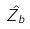<formula> <loc_0><loc_0><loc_500><loc_500>\hat { Z _ { b } }</formula> 